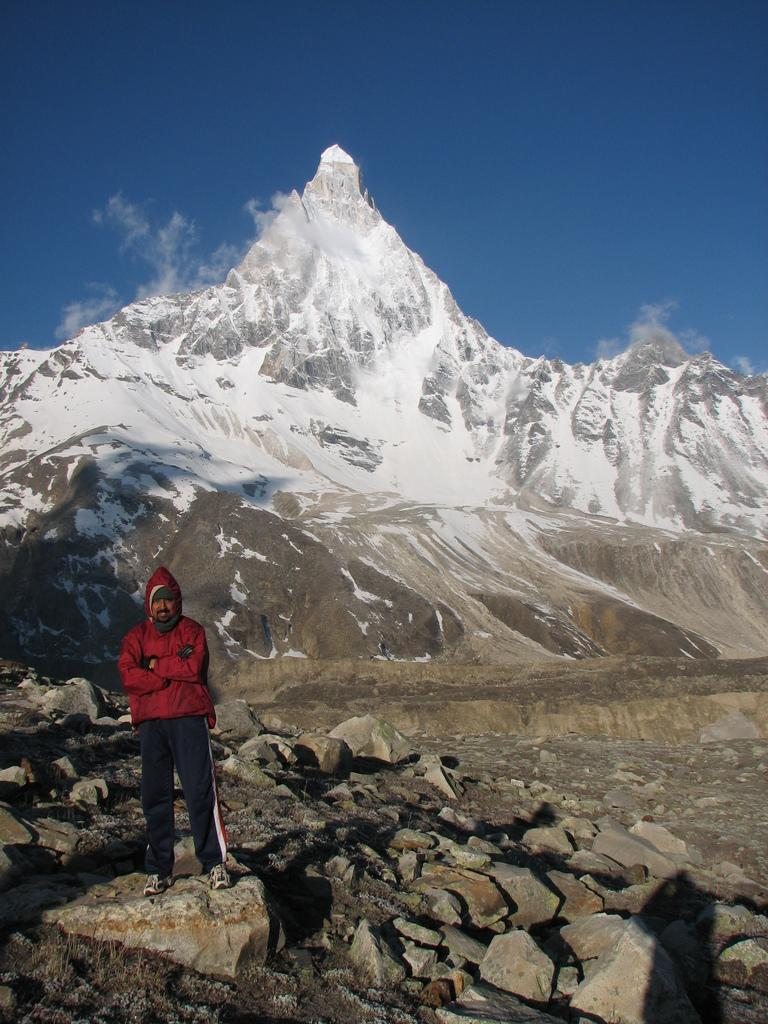What is the main subject in the image? There is a person standing in the image. What type of natural features can be seen in the image? There are rocks and mountains in the image. What is visible in the background of the image? The sky is visible in the background of the image. How many babies are crawling on the rocks in the image? There are no babies present in the image; it only features a person standing, rocks, mountains, and the sky. 